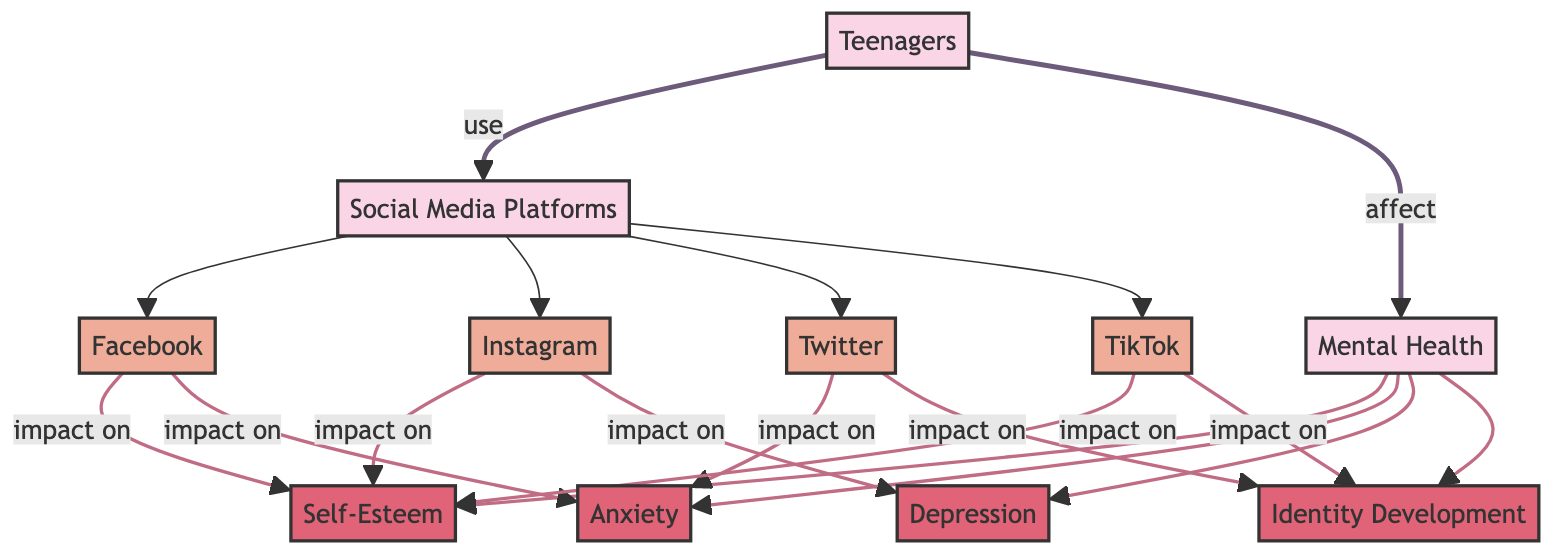What social media platforms are included in the diagram? The diagram lists four social media platforms: Facebook, Instagram, Twitter, and TikTok, which are connected to the main category of Social Media Platforms.
Answer: Facebook, Instagram, Twitter, TikTok How many mental health factors are shown in the diagram? The diagram includes four mental health factors: Self-Esteem, Anxiety, Depression, and Identity Development, all stemming from the Mental Health category.
Answer: Four What is the relationship between Facebook and anxiety? The diagram indicates that Facebook has an impact on both Self-Esteem and Anxiety, establishing a direct connection to Anxiety.
Answer: Impact Which platform primarily impacts identity development? From the diagram, Twitter and TikTok both have direct relationships that impact Identity Development, but Twitter specifically is one of the main platforms indicated.
Answer: Twitter How do teenagers affect their mental health according to the diagram? The diagram shows that teenagers use social media platforms, and this usage affects their mental health. The relationship indicates a direct path from Teenagers to Mental Health.
Answer: Affect What is the primary mental health factor impacted by Instagram? According to the diagram, Instagram impacts both Self-Esteem and Depression, but the key focus for Mental Health is primarily Depression as indicated by its connecting line.
Answer: Depression Which social media platform affects self-esteem the most? The diagram highlights that both Facebook and TikTok impact Self-Esteem, but Facebook has a direct line indicating a stronger influence.
Answer: Facebook What is the flow of the diagram regarding the impact of social media usage? The flow establishes that social media platforms influence teenagers who then affect various mental health factors, showing an integrated relationship among these elements.
Answer: Integrated relationship Which mental health factors are linked to TikTok according to the diagram? The diagram shows that TikTok has an impact on Self-Esteem and Identity Development, establishing connections to both of these mental health factors.
Answer: Self-Esteem, Identity Development 